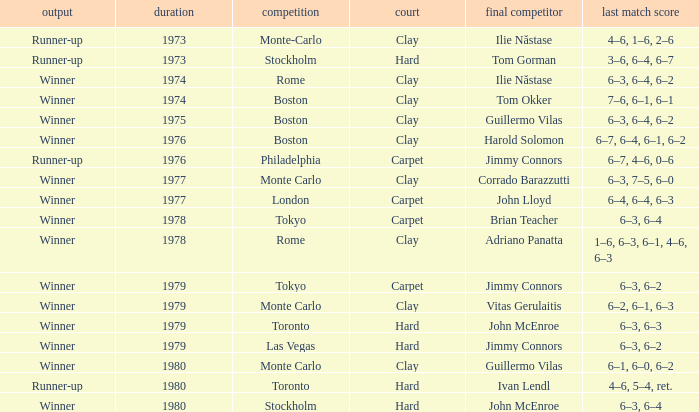Name the year for clay for boston and guillermo vilas 1975.0. 